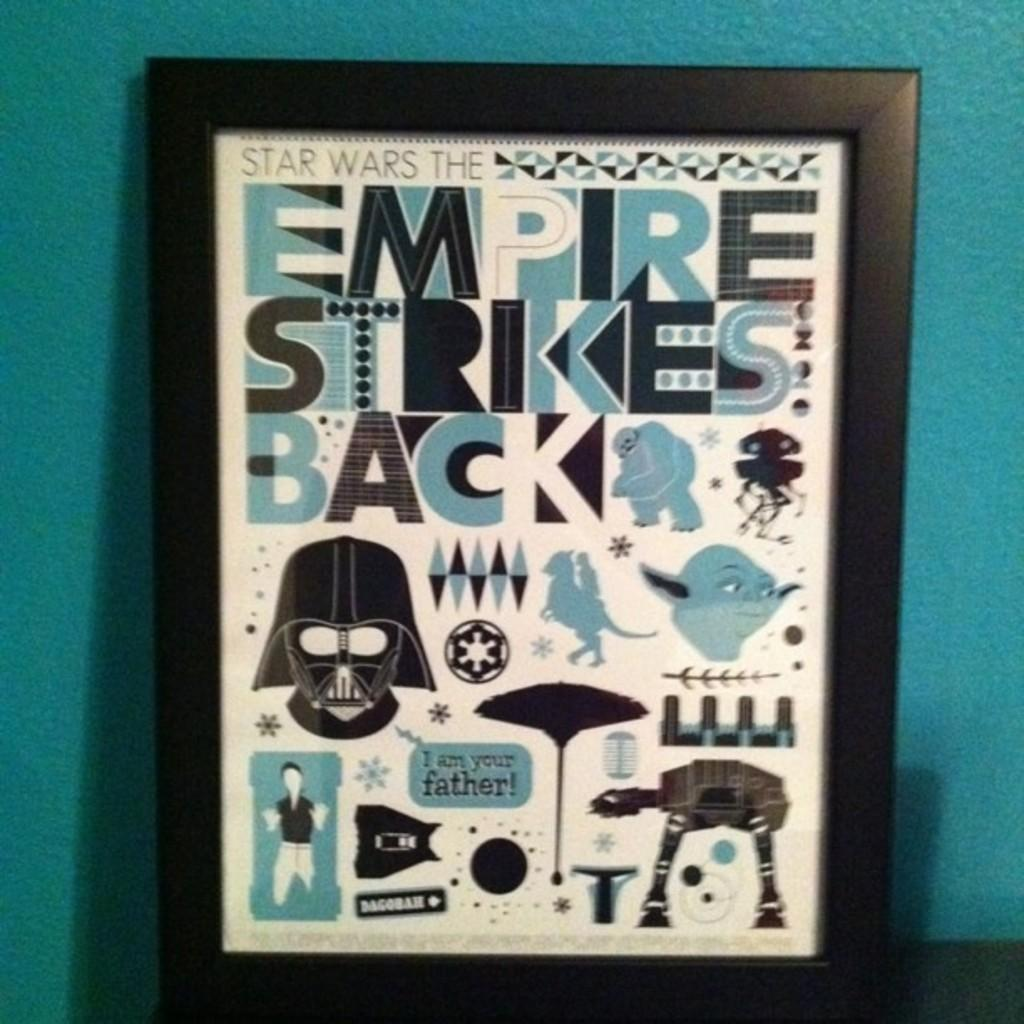Provide a one-sentence caption for the provided image. Empire strikes back sign inside a picture frame. 